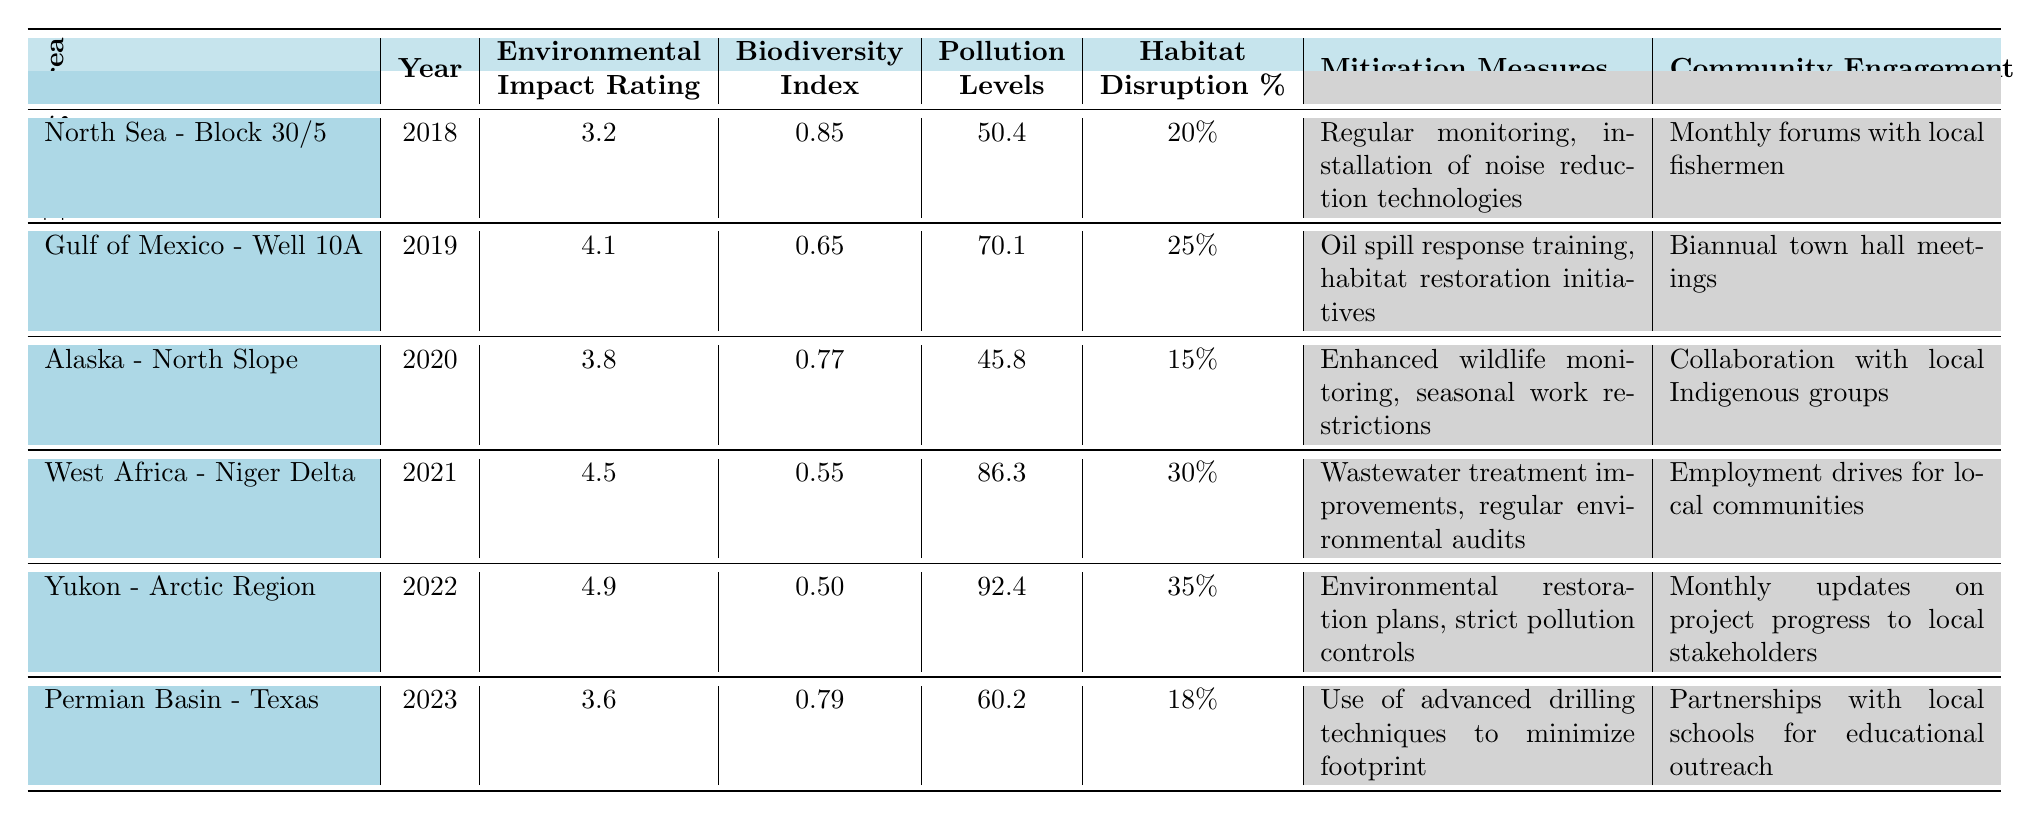What is the Environmental Impact Rating for the Yukon - Arctic Region in 2022? The table directly shows that the Environmental Impact Rating for the Yukon - Arctic Region in 2022 is 4.9.
Answer: 4.9 Which drilling area had the highest Pollution Levels? Looking at the Pollution Levels across the drilling areas, the Yukon - Arctic Region in 2022 has the highest level at 92.4.
Answer: Yukon - Arctic Region What is the average Biodiversity Index for all drilling areas from 2018 to 2023? To find the average, sum the Biodiversity Index values (0.85 + 0.65 + 0.77 + 0.55 + 0.50 + 0.79 = 4.11) and divide by the number of drilling areas (6), which is 4.11 / 6 = 0.685.
Answer: 0.685 Did the Environmental Impact Ratings increase from 2020 to 2022? The ratings were 3.8 in 2020 and 4.9 in 2022. Since 4.9 is greater than 3.8, the ratings increased over that period.
Answer: Yes What is the habitat disruption percentage for the Gulf of Mexico - Well 10A in 2019, and is it greater than the percentage for Permian Basin - Texas in 2023? The Gulf of Mexico - Well 10A has a habitat disruption percentage of 25%. The Permian Basin - Texas has a percentage of 18%. Since 25% is greater than 18%, it is confirmed.
Answer: Yes Which drilling area exhibited both the highest Environmental Impact Rating and Pollution Levels? The table shows that the Yukon - Arctic Region has the highest Environmental Impact Rating (4.9) and also the highest Pollution Levels (92.4). Therefore, it meets both conditions.
Answer: Yukon - Arctic Region How many drilling areas had an Environmental Impact Rating below 4.0? The table lists the Environmental Impact Ratings: (3.2, 4.1, 3.8, 4.5, 4.9, 3.6). The areas with ratings below 4.0 are North Sea - Block 30/5 (3.2), Alaska - North Slope (3.8), and Permian Basin - Texas (3.6), totaling 3 areas.
Answer: 3 Is there any drilling area that showed improvement in both Biodiversity Index and Environmental Impact Rating from 2021 to 2022? In 2021, West Africa - Niger Delta had a Biodiversity Index of 0.55 and an Environmental Impact Rating of 4.5. In 2022, the Yukon - Arctic Region had a Biodiversity Index of 0.50 and a rating of 4.9. Since both metrics decreased for the Niger Delta and the Biodiversity Index also decreased for the Yukon, there was no improvement in both metrics.
Answer: No Which mitigation measure was consistently implemented across all drilling areas? By examining the Mitigation Measures column, it is noted that there is no identical measure applied across all areas, as each area has unique measures tailored to its specifics.
Answer: None 